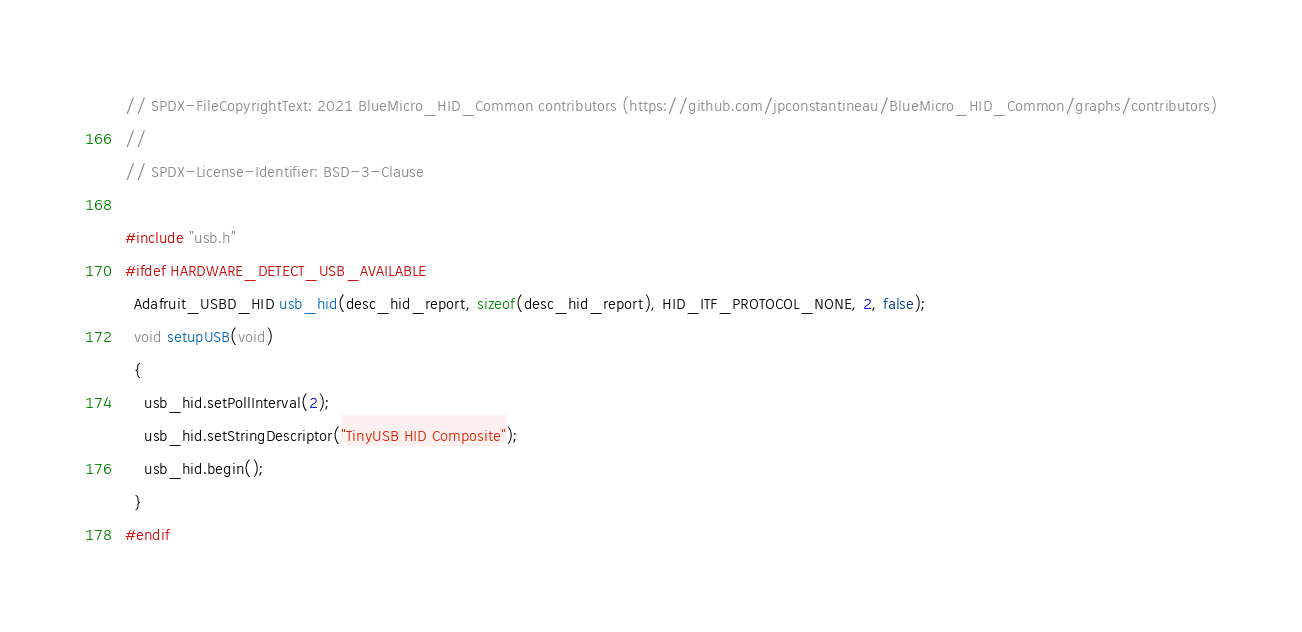Convert code to text. <code><loc_0><loc_0><loc_500><loc_500><_C++_>// SPDX-FileCopyrightText: 2021 BlueMicro_HID_Common contributors (https://github.com/jpconstantineau/BlueMicro_HID_Common/graphs/contributors)
//
// SPDX-License-Identifier: BSD-3-Clause

#include "usb.h"
#ifdef HARDWARE_DETECT_USB_AVAILABLE
  Adafruit_USBD_HID usb_hid(desc_hid_report, sizeof(desc_hid_report), HID_ITF_PROTOCOL_NONE, 2, false);
  void setupUSB(void)
  {
    usb_hid.setPollInterval(2);
    usb_hid.setStringDescriptor("TinyUSB HID Composite");
    usb_hid.begin();
  }
#endif
</code> 